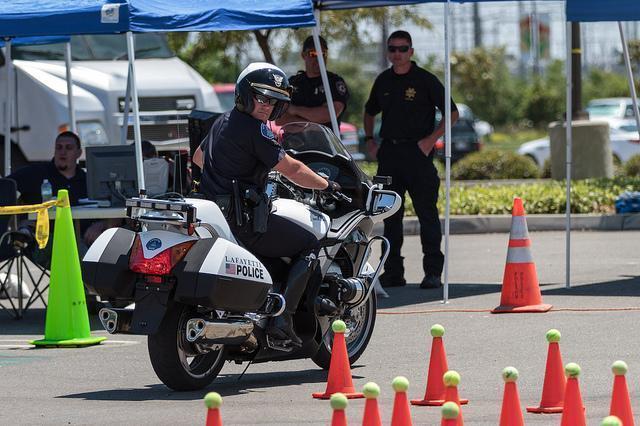What locale does the policeman serve?
Make your selection and explain in format: 'Answer: answer
Rationale: rationale.'
Options: Bloomington, lafayette, shreveport, monroe. Answer: lafayette.
Rationale: The decal on the policeman's motorcycle names this city. 